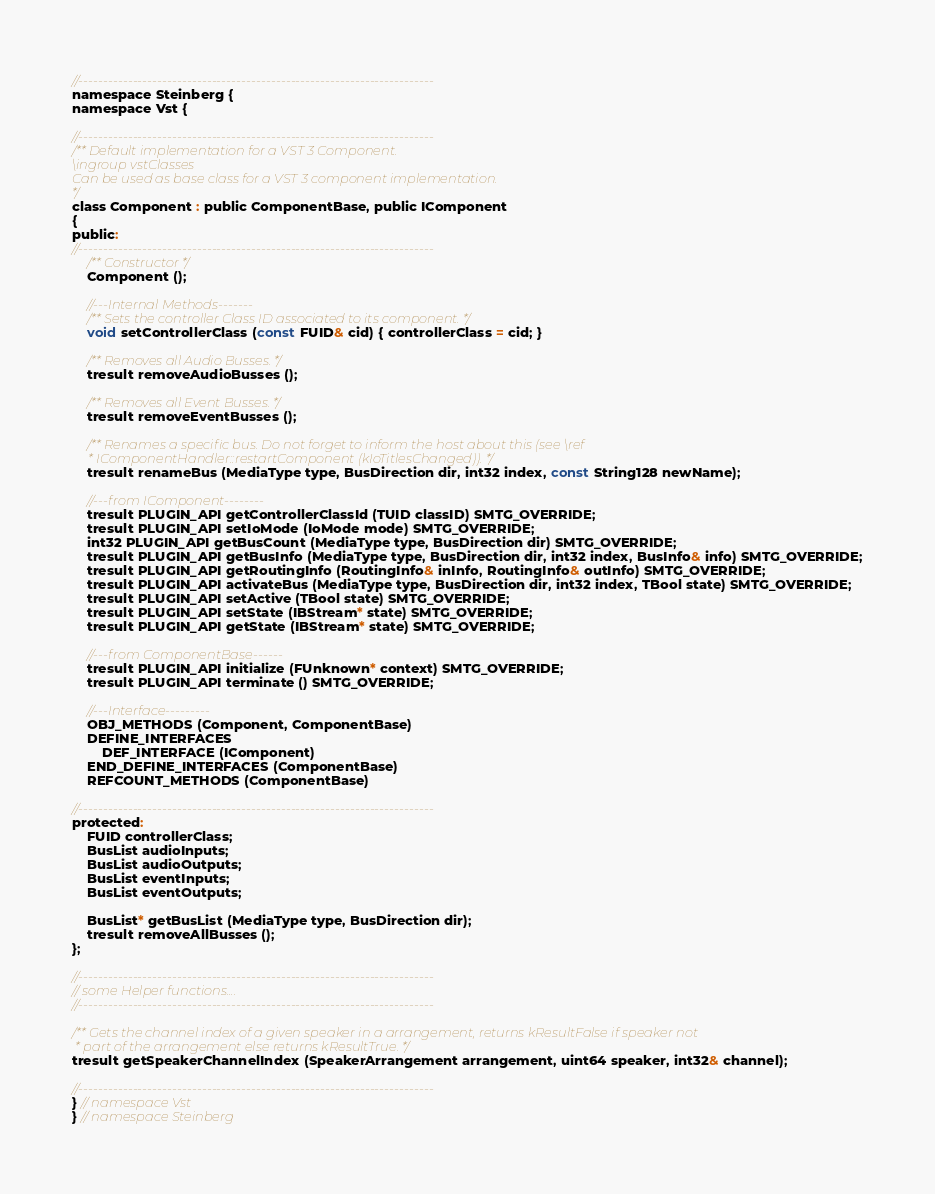<code> <loc_0><loc_0><loc_500><loc_500><_C_>//------------------------------------------------------------------------
namespace Steinberg {
namespace Vst {

//------------------------------------------------------------------------
/** Default implementation for a VST 3 Component.
\ingroup vstClasses
Can be used as base class for a VST 3 component implementation.
*/
class Component : public ComponentBase, public IComponent
{
public:
//------------------------------------------------------------------------
	/** Constructor */
	Component ();

	//---Internal Methods-------
	/** Sets the controller Class ID associated to its component. */
	void setControllerClass (const FUID& cid) { controllerClass = cid; }

	/** Removes all Audio Busses. */
	tresult removeAudioBusses ();

	/** Removes all Event Busses. */
	tresult removeEventBusses ();

	/** Renames a specific bus. Do not forget to inform the host about this (see \ref
	 * IComponentHandler::restartComponent (kIoTitlesChanged)). */
	tresult renameBus (MediaType type, BusDirection dir, int32 index, const String128 newName);

	//---from IComponent--------
	tresult PLUGIN_API getControllerClassId (TUID classID) SMTG_OVERRIDE;
	tresult PLUGIN_API setIoMode (IoMode mode) SMTG_OVERRIDE;
	int32 PLUGIN_API getBusCount (MediaType type, BusDirection dir) SMTG_OVERRIDE;
	tresult PLUGIN_API getBusInfo (MediaType type, BusDirection dir, int32 index, BusInfo& info) SMTG_OVERRIDE;
	tresult PLUGIN_API getRoutingInfo (RoutingInfo& inInfo, RoutingInfo& outInfo) SMTG_OVERRIDE;
	tresult PLUGIN_API activateBus (MediaType type, BusDirection dir, int32 index, TBool state) SMTG_OVERRIDE;
	tresult PLUGIN_API setActive (TBool state) SMTG_OVERRIDE;
	tresult PLUGIN_API setState (IBStream* state) SMTG_OVERRIDE;
	tresult PLUGIN_API getState (IBStream* state) SMTG_OVERRIDE;

	//---from ComponentBase------
	tresult PLUGIN_API initialize (FUnknown* context) SMTG_OVERRIDE;
	tresult PLUGIN_API terminate () SMTG_OVERRIDE;

	//---Interface---------
	OBJ_METHODS (Component, ComponentBase)
	DEFINE_INTERFACES
		DEF_INTERFACE (IComponent)
	END_DEFINE_INTERFACES (ComponentBase)
	REFCOUNT_METHODS (ComponentBase)

//------------------------------------------------------------------------
protected:
	FUID controllerClass;
	BusList audioInputs;
	BusList audioOutputs;
	BusList eventInputs;
	BusList eventOutputs;

	BusList* getBusList (MediaType type, BusDirection dir);
	tresult removeAllBusses ();
};

//------------------------------------------------------------------------
// some Helper functions....
//------------------------------------------------------------------------

/** Gets the channel index of a given speaker in a arrangement, returns kResultFalse if speaker not
 * part of the arrangement else returns kResultTrue. */
tresult getSpeakerChannelIndex (SpeakerArrangement arrangement, uint64 speaker, int32& channel);

//------------------------------------------------------------------------
} // namespace Vst
} // namespace Steinberg
</code> 